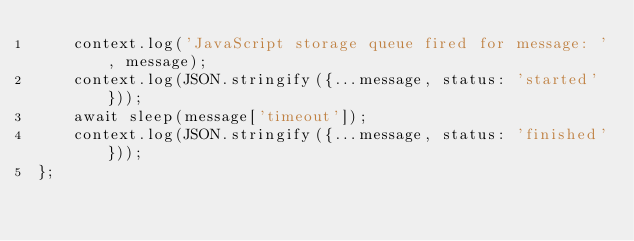<code> <loc_0><loc_0><loc_500><loc_500><_JavaScript_>    context.log('JavaScript storage queue fired for message: ', message);
    context.log(JSON.stringify({...message, status: 'started'}));
    await sleep(message['timeout']);
    context.log(JSON.stringify({...message, status: 'finished'}));
};</code> 